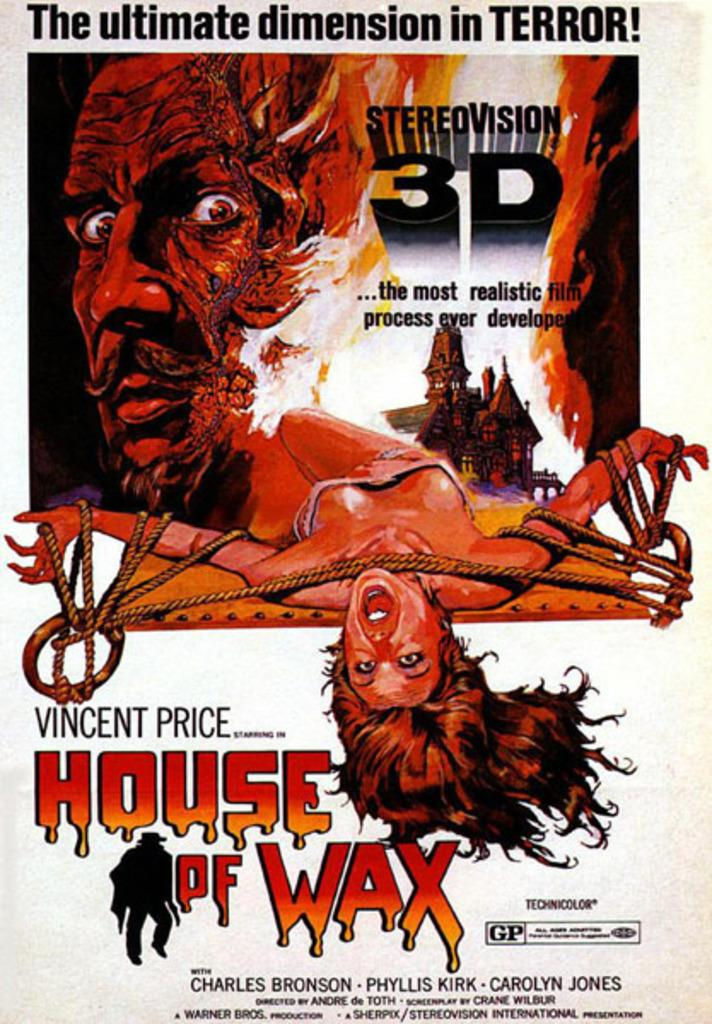Provide a one-sentence caption for the provided image. Vincent price starts in House of Wax on a poster promoting the film. 